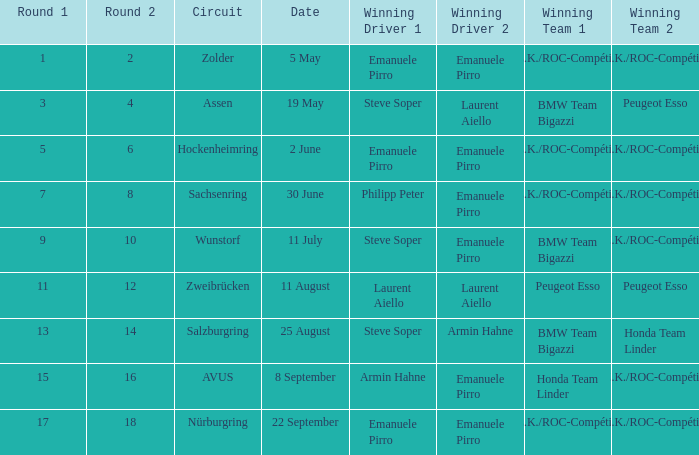What is the round on 30 June with a.z.k./roc-compétition a.z.k./roc-compétition as the winning team? 7 8. 